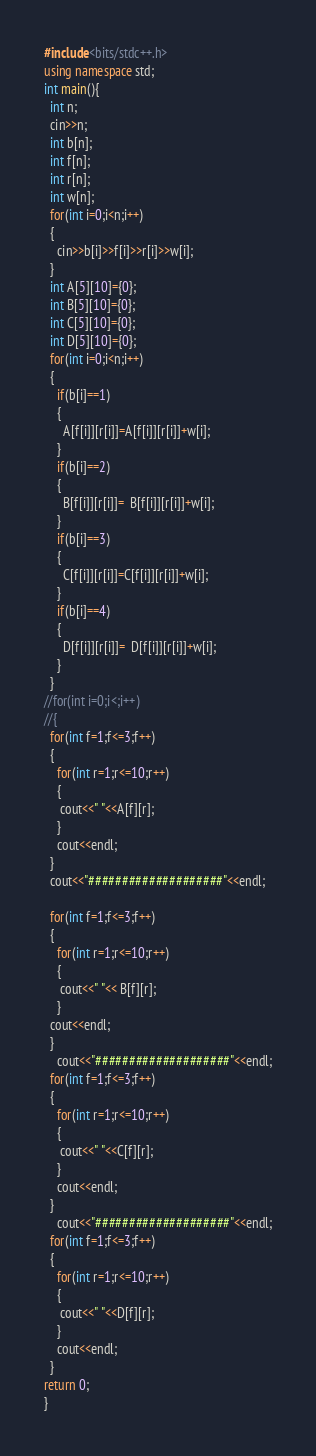Convert code to text. <code><loc_0><loc_0><loc_500><loc_500><_C++_>#include<bits/stdc++.h>
using namespace std;
int main(){
  int n;
  cin>>n;
  int b[n];
  int f[n];
  int r[n];
  int w[n];
  for(int i=0;i<n;i++)
  {
    cin>>b[i]>>f[i]>>r[i]>>w[i];
  }
  int A[5][10]={0};
  int B[5][10]={0};
  int C[5][10]={0};
  int D[5][10]={0};
  for(int i=0;i<n;i++)
  {
    if(b[i]==1)
    {
      A[f[i]][r[i]]=A[f[i]][r[i]]+w[i];
    }
    if(b[i]==2)
    {
      B[f[i]][r[i]]=  B[f[i]][r[i]]+w[i];
    }
    if(b[i]==3)
    {
      C[f[i]][r[i]]=C[f[i]][r[i]]+w[i];
    }
    if(b[i]==4)
    {
      D[f[i]][r[i]]=  D[f[i]][r[i]]+w[i];
    }
  }
//for(int i=0;i<;i++)
//{
  for(int f=1;f<=3;f++)
  {
    for(int r=1;r<=10;r++)
    {
     cout<<" "<<A[f][r];
    }
    cout<<endl;
  }
  cout<<"####################"<<endl;

  for(int f=1;f<=3;f++)
  {
    for(int r=1;r<=10;r++)
    {
     cout<<" "<< B[f][r];
    }
  cout<<endl;
  }
    cout<<"####################"<<endl;
  for(int f=1;f<=3;f++)
  {
    for(int r=1;r<=10;r++)
    {
     cout<<" "<<C[f][r];
    }
    cout<<endl;
  }
    cout<<"####################"<<endl;
  for(int f=1;f<=3;f++)
  {
    for(int r=1;r<=10;r++)
    {
     cout<<" "<<D[f][r];
    }
    cout<<endl;
  }
return 0;
}

</code> 